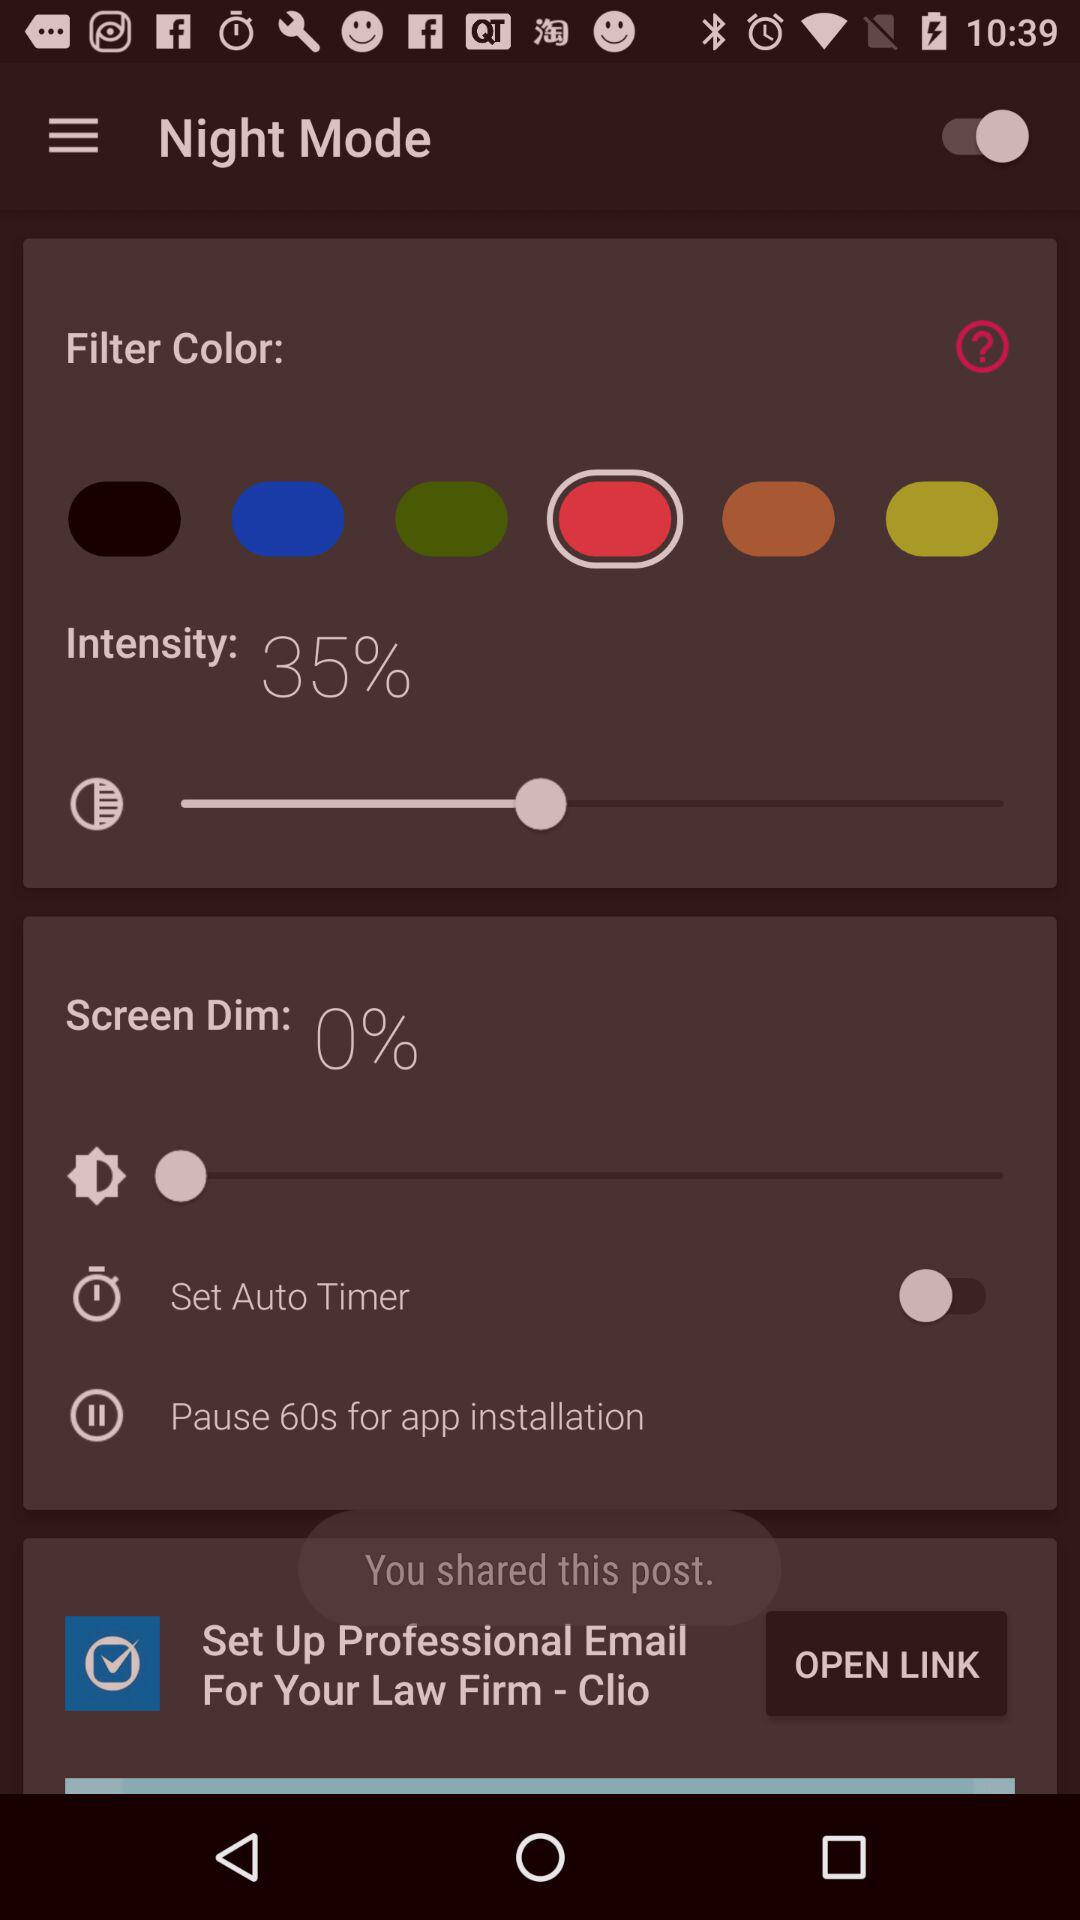For how much time to pause? Pause for 60 seconds. 